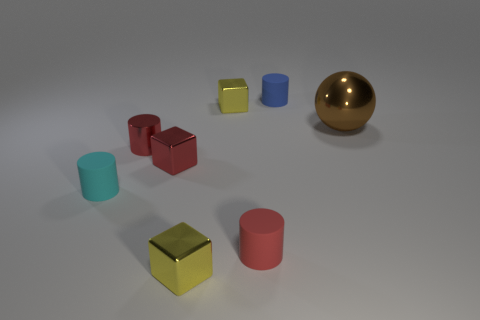Which objects have reflective surfaces? The objects with reflective surfaces in the image are the large gold sphere and the larger red cube. These surfaces are shiny, indicating that they are likely made of a material that reflects light well, such as metal or polished plastic. 